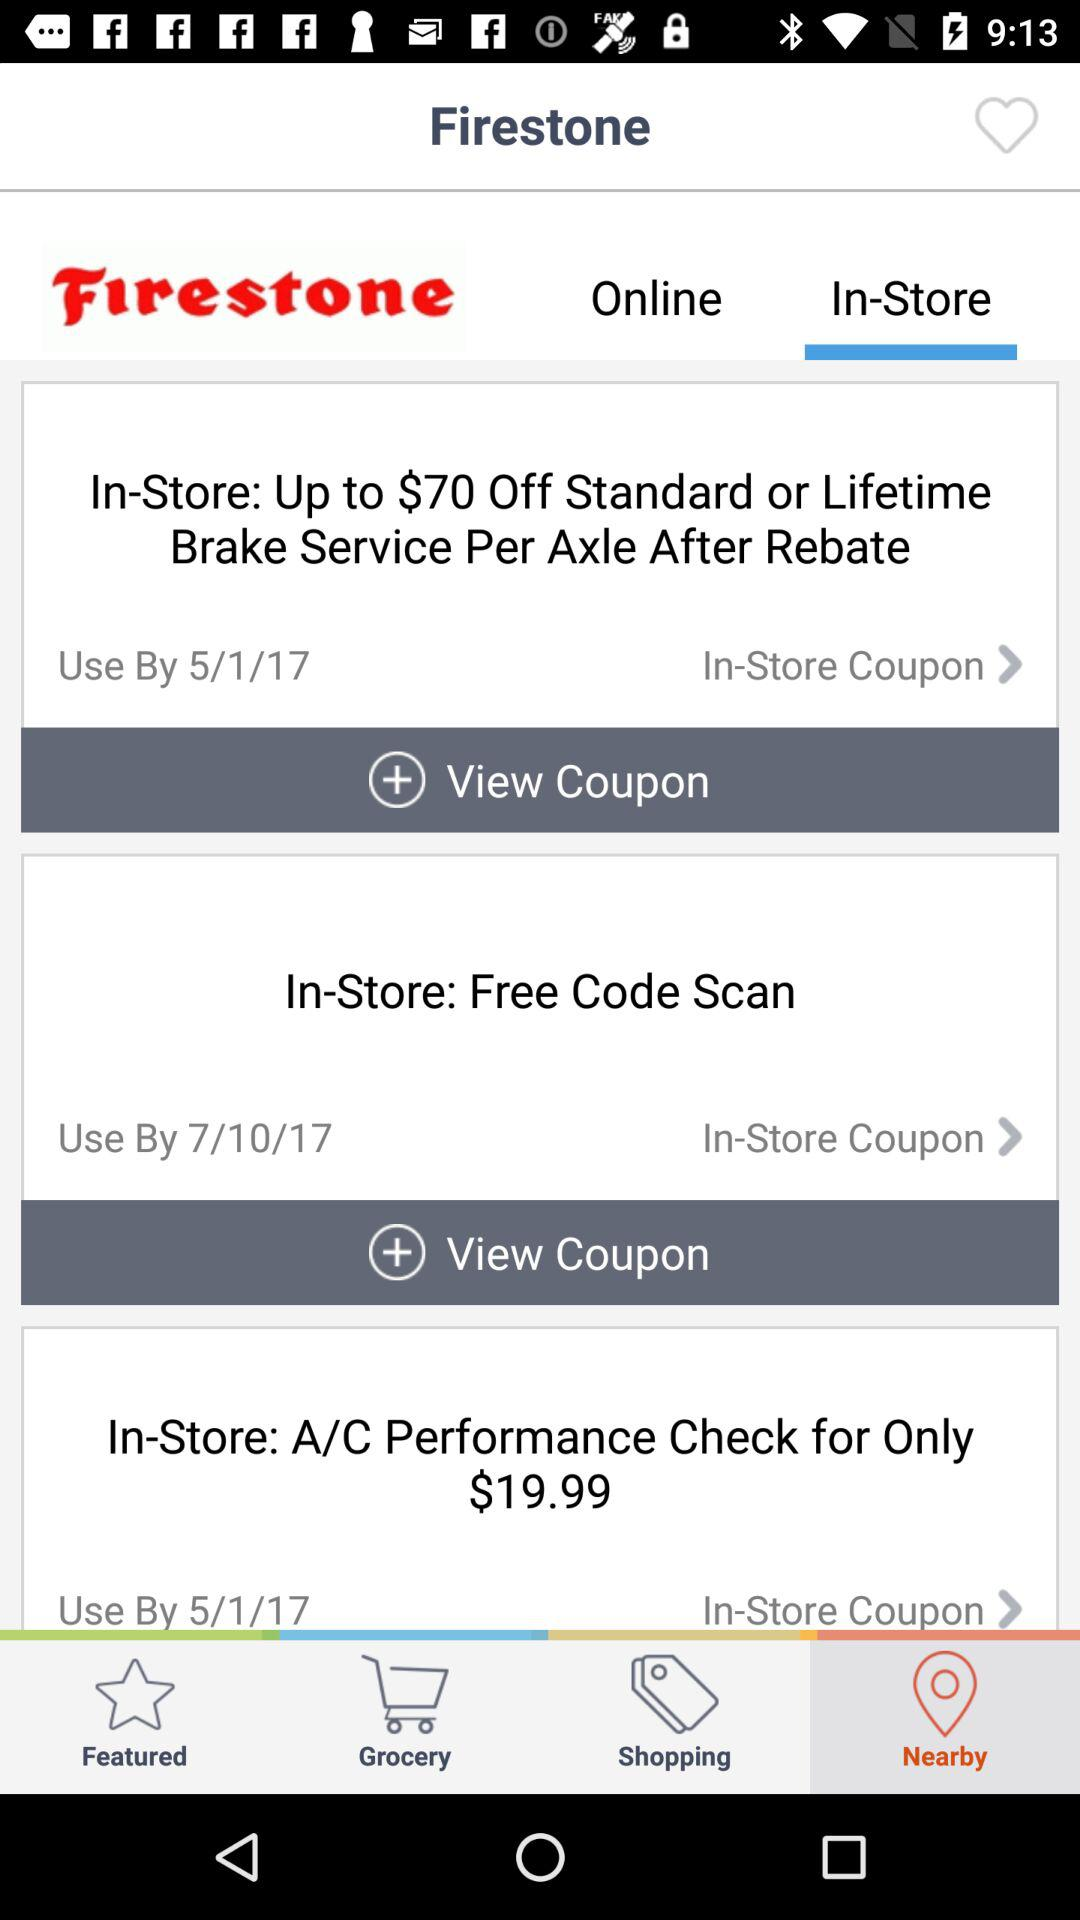Till what date will "In-store: free code scan" be used? The date is 7/10/17. 